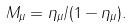Convert formula to latex. <formula><loc_0><loc_0><loc_500><loc_500>M _ { \mu } = \eta _ { \mu } / ( 1 - \eta _ { \mu } ) .</formula> 